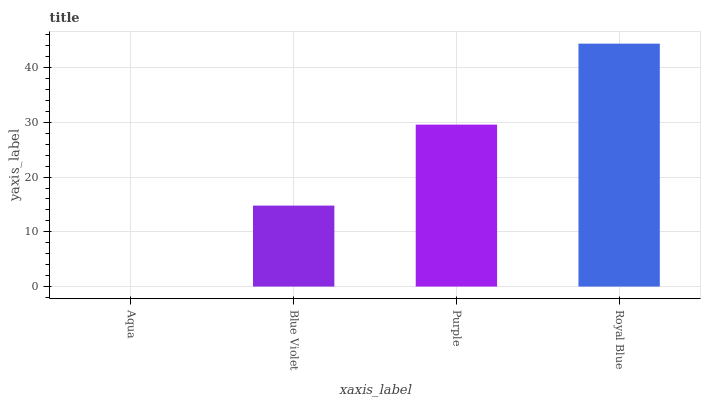Is Blue Violet the minimum?
Answer yes or no. No. Is Blue Violet the maximum?
Answer yes or no. No. Is Blue Violet greater than Aqua?
Answer yes or no. Yes. Is Aqua less than Blue Violet?
Answer yes or no. Yes. Is Aqua greater than Blue Violet?
Answer yes or no. No. Is Blue Violet less than Aqua?
Answer yes or no. No. Is Purple the high median?
Answer yes or no. Yes. Is Blue Violet the low median?
Answer yes or no. Yes. Is Royal Blue the high median?
Answer yes or no. No. Is Royal Blue the low median?
Answer yes or no. No. 